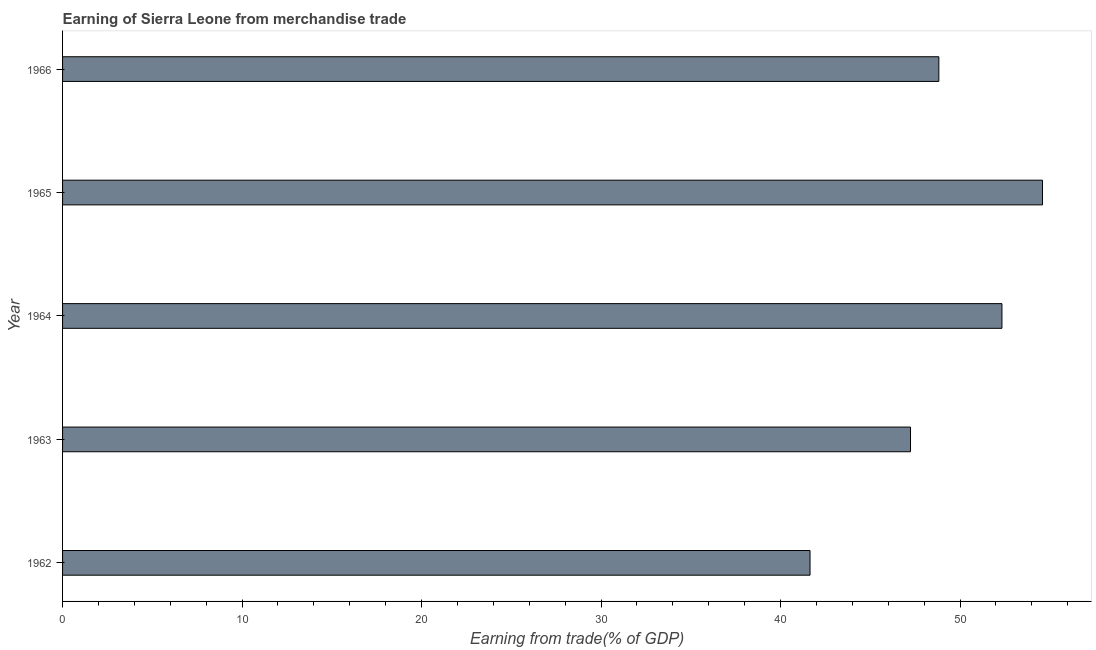What is the title of the graph?
Offer a very short reply. Earning of Sierra Leone from merchandise trade. What is the label or title of the X-axis?
Offer a terse response. Earning from trade(% of GDP). What is the label or title of the Y-axis?
Provide a short and direct response. Year. What is the earning from merchandise trade in 1963?
Make the answer very short. 47.24. Across all years, what is the maximum earning from merchandise trade?
Provide a short and direct response. 54.59. Across all years, what is the minimum earning from merchandise trade?
Provide a succinct answer. 41.64. In which year was the earning from merchandise trade maximum?
Provide a succinct answer. 1965. In which year was the earning from merchandise trade minimum?
Your response must be concise. 1962. What is the sum of the earning from merchandise trade?
Keep it short and to the point. 244.63. What is the difference between the earning from merchandise trade in 1963 and 1964?
Make the answer very short. -5.09. What is the average earning from merchandise trade per year?
Give a very brief answer. 48.92. What is the median earning from merchandise trade?
Your answer should be compact. 48.82. In how many years, is the earning from merchandise trade greater than 14 %?
Ensure brevity in your answer.  5. What is the ratio of the earning from merchandise trade in 1963 to that in 1965?
Provide a succinct answer. 0.86. Is the earning from merchandise trade in 1964 less than that in 1966?
Ensure brevity in your answer.  No. Is the difference between the earning from merchandise trade in 1962 and 1965 greater than the difference between any two years?
Offer a very short reply. Yes. What is the difference between the highest and the second highest earning from merchandise trade?
Your answer should be very brief. 2.26. What is the difference between the highest and the lowest earning from merchandise trade?
Keep it short and to the point. 12.95. In how many years, is the earning from merchandise trade greater than the average earning from merchandise trade taken over all years?
Your response must be concise. 2. What is the difference between two consecutive major ticks on the X-axis?
Your answer should be very brief. 10. Are the values on the major ticks of X-axis written in scientific E-notation?
Give a very brief answer. No. What is the Earning from trade(% of GDP) of 1962?
Keep it short and to the point. 41.64. What is the Earning from trade(% of GDP) in 1963?
Offer a terse response. 47.24. What is the Earning from trade(% of GDP) in 1964?
Keep it short and to the point. 52.33. What is the Earning from trade(% of GDP) in 1965?
Your response must be concise. 54.59. What is the Earning from trade(% of GDP) in 1966?
Make the answer very short. 48.82. What is the difference between the Earning from trade(% of GDP) in 1962 and 1963?
Provide a succinct answer. -5.6. What is the difference between the Earning from trade(% of GDP) in 1962 and 1964?
Keep it short and to the point. -10.69. What is the difference between the Earning from trade(% of GDP) in 1962 and 1965?
Offer a very short reply. -12.95. What is the difference between the Earning from trade(% of GDP) in 1962 and 1966?
Ensure brevity in your answer.  -7.18. What is the difference between the Earning from trade(% of GDP) in 1963 and 1964?
Give a very brief answer. -5.09. What is the difference between the Earning from trade(% of GDP) in 1963 and 1965?
Provide a succinct answer. -7.35. What is the difference between the Earning from trade(% of GDP) in 1963 and 1966?
Your answer should be very brief. -1.58. What is the difference between the Earning from trade(% of GDP) in 1964 and 1965?
Your answer should be very brief. -2.26. What is the difference between the Earning from trade(% of GDP) in 1964 and 1966?
Keep it short and to the point. 3.52. What is the difference between the Earning from trade(% of GDP) in 1965 and 1966?
Your answer should be compact. 5.77. What is the ratio of the Earning from trade(% of GDP) in 1962 to that in 1963?
Your response must be concise. 0.88. What is the ratio of the Earning from trade(% of GDP) in 1962 to that in 1964?
Offer a terse response. 0.8. What is the ratio of the Earning from trade(% of GDP) in 1962 to that in 1965?
Keep it short and to the point. 0.76. What is the ratio of the Earning from trade(% of GDP) in 1962 to that in 1966?
Your answer should be compact. 0.85. What is the ratio of the Earning from trade(% of GDP) in 1963 to that in 1964?
Keep it short and to the point. 0.9. What is the ratio of the Earning from trade(% of GDP) in 1963 to that in 1965?
Your answer should be compact. 0.86. What is the ratio of the Earning from trade(% of GDP) in 1963 to that in 1966?
Provide a succinct answer. 0.97. What is the ratio of the Earning from trade(% of GDP) in 1964 to that in 1966?
Offer a terse response. 1.07. What is the ratio of the Earning from trade(% of GDP) in 1965 to that in 1966?
Make the answer very short. 1.12. 